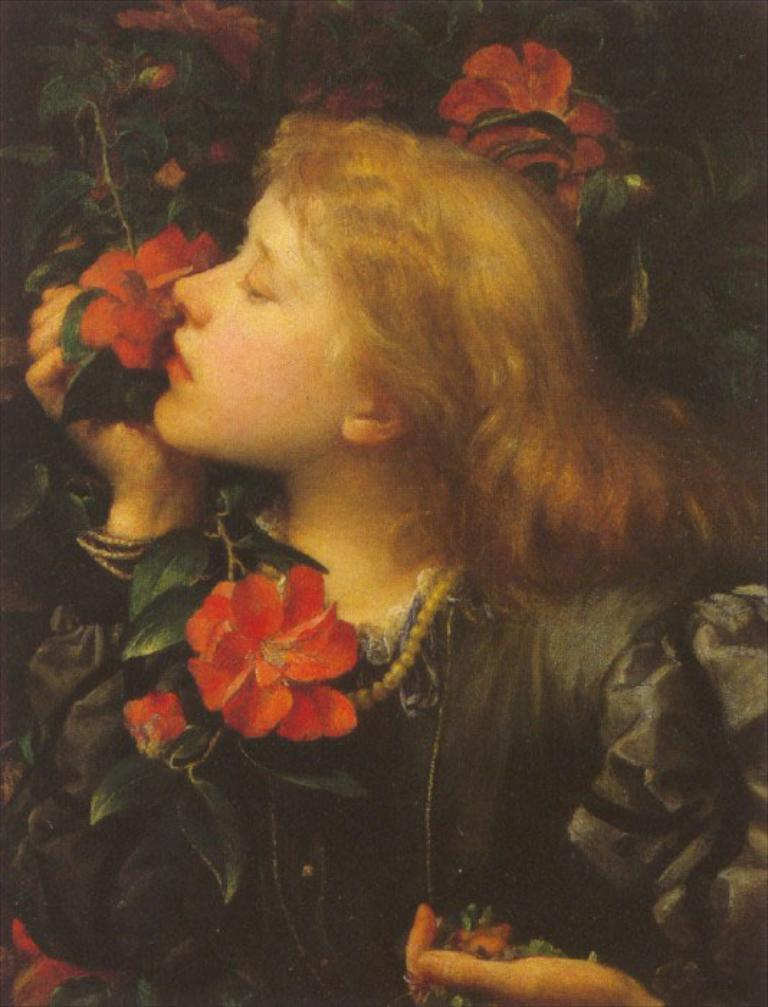What is the main subject of the image? There is a depiction of a woman in the image. What other elements can be seen in the image? There are flowers in the image. What type of fowl can be seen interacting with the woman in the image? There is no fowl present in the image; it only features a depiction of a woman and flowers. What sense is being stimulated by the flowers in the image? The image does not provide information about which sense is being stimulated by the flowers. 